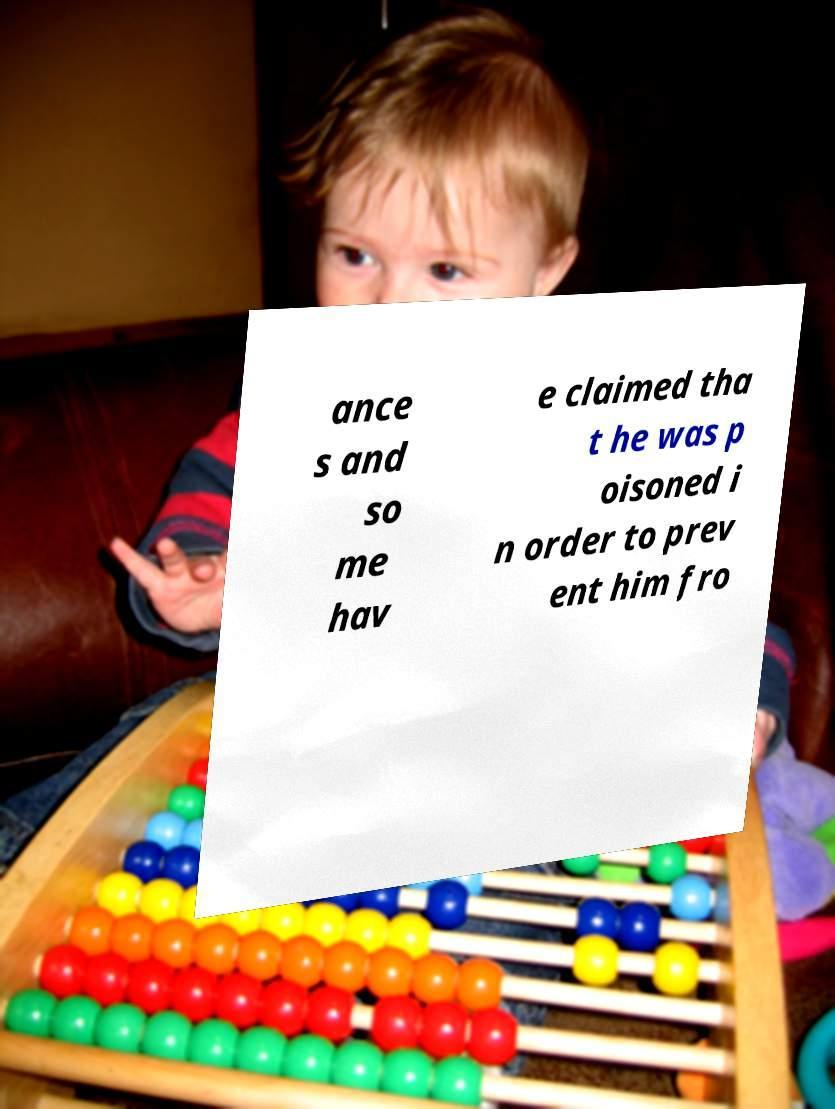Could you extract and type out the text from this image? ance s and so me hav e claimed tha t he was p oisoned i n order to prev ent him fro 